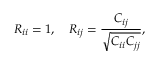Convert formula to latex. <formula><loc_0><loc_0><loc_500><loc_500>R _ { i i } = 1 , \quad R _ { i j } = \frac { C _ { i j } } { \sqrt { C _ { i i } C _ { j j } } } ,</formula> 